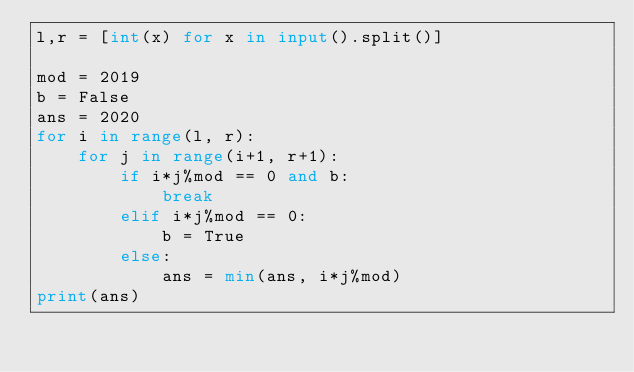Convert code to text. <code><loc_0><loc_0><loc_500><loc_500><_Python_>l,r = [int(x) for x in input().split()]

mod = 2019
b = False
ans = 2020
for i in range(l, r):
    for j in range(i+1, r+1):
        if i*j%mod == 0 and b:
            break
        elif i*j%mod == 0:
            b = True
        else:
            ans = min(ans, i*j%mod)
print(ans)</code> 